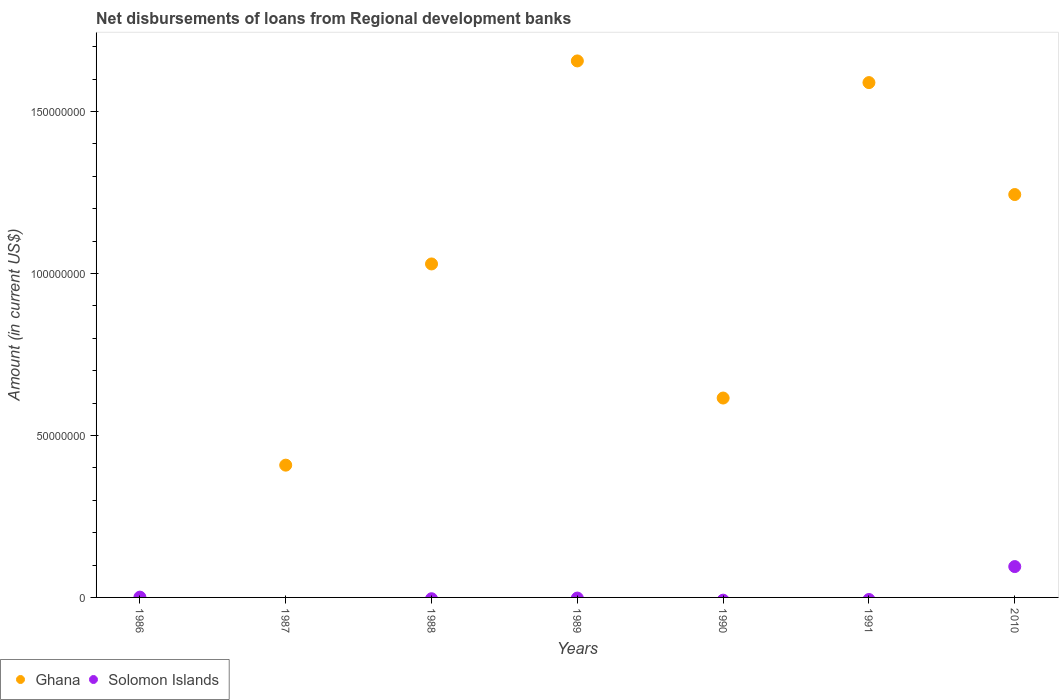How many different coloured dotlines are there?
Your response must be concise. 2. Is the number of dotlines equal to the number of legend labels?
Make the answer very short. No. What is the amount of disbursements of loans from regional development banks in Ghana in 1990?
Ensure brevity in your answer.  6.15e+07. Across all years, what is the maximum amount of disbursements of loans from regional development banks in Solomon Islands?
Offer a very short reply. 9.52e+06. In which year was the amount of disbursements of loans from regional development banks in Solomon Islands maximum?
Offer a terse response. 2010. What is the total amount of disbursements of loans from regional development banks in Ghana in the graph?
Provide a short and direct response. 6.54e+08. What is the difference between the amount of disbursements of loans from regional development banks in Ghana in 1989 and that in 2010?
Your response must be concise. 4.12e+07. What is the difference between the amount of disbursements of loans from regional development banks in Solomon Islands in 1988 and the amount of disbursements of loans from regional development banks in Ghana in 2010?
Offer a terse response. -1.24e+08. What is the average amount of disbursements of loans from regional development banks in Ghana per year?
Keep it short and to the point. 9.35e+07. What is the ratio of the amount of disbursements of loans from regional development banks in Ghana in 1990 to that in 1991?
Keep it short and to the point. 0.39. What is the difference between the highest and the second highest amount of disbursements of loans from regional development banks in Ghana?
Ensure brevity in your answer.  6.69e+06. What is the difference between the highest and the lowest amount of disbursements of loans from regional development banks in Ghana?
Offer a very short reply. 1.66e+08. Is the sum of the amount of disbursements of loans from regional development banks in Ghana in 1987 and 1988 greater than the maximum amount of disbursements of loans from regional development banks in Solomon Islands across all years?
Your answer should be compact. Yes. Does the amount of disbursements of loans from regional development banks in Ghana monotonically increase over the years?
Your answer should be very brief. No. Is the amount of disbursements of loans from regional development banks in Solomon Islands strictly greater than the amount of disbursements of loans from regional development banks in Ghana over the years?
Keep it short and to the point. No. How many dotlines are there?
Give a very brief answer. 2. How many legend labels are there?
Your answer should be very brief. 2. What is the title of the graph?
Your answer should be compact. Net disbursements of loans from Regional development banks. What is the label or title of the X-axis?
Ensure brevity in your answer.  Years. What is the label or title of the Y-axis?
Offer a terse response. Amount (in current US$). What is the Amount (in current US$) of Ghana in 1986?
Provide a short and direct response. 0. What is the Amount (in current US$) of Solomon Islands in 1986?
Your answer should be compact. 9.10e+04. What is the Amount (in current US$) in Ghana in 1987?
Your answer should be very brief. 4.08e+07. What is the Amount (in current US$) in Ghana in 1988?
Your response must be concise. 1.03e+08. What is the Amount (in current US$) of Solomon Islands in 1988?
Make the answer very short. 0. What is the Amount (in current US$) in Ghana in 1989?
Your response must be concise. 1.66e+08. What is the Amount (in current US$) of Ghana in 1990?
Provide a short and direct response. 6.15e+07. What is the Amount (in current US$) in Solomon Islands in 1990?
Offer a very short reply. 0. What is the Amount (in current US$) of Ghana in 1991?
Offer a very short reply. 1.59e+08. What is the Amount (in current US$) in Solomon Islands in 1991?
Keep it short and to the point. 0. What is the Amount (in current US$) of Ghana in 2010?
Ensure brevity in your answer.  1.24e+08. What is the Amount (in current US$) of Solomon Islands in 2010?
Offer a terse response. 9.52e+06. Across all years, what is the maximum Amount (in current US$) in Ghana?
Provide a succinct answer. 1.66e+08. Across all years, what is the maximum Amount (in current US$) in Solomon Islands?
Offer a terse response. 9.52e+06. Across all years, what is the minimum Amount (in current US$) in Ghana?
Offer a terse response. 0. Across all years, what is the minimum Amount (in current US$) in Solomon Islands?
Your response must be concise. 0. What is the total Amount (in current US$) in Ghana in the graph?
Ensure brevity in your answer.  6.54e+08. What is the total Amount (in current US$) in Solomon Islands in the graph?
Your answer should be compact. 9.61e+06. What is the difference between the Amount (in current US$) in Solomon Islands in 1986 and that in 2010?
Give a very brief answer. -9.43e+06. What is the difference between the Amount (in current US$) of Ghana in 1987 and that in 1988?
Offer a very short reply. -6.21e+07. What is the difference between the Amount (in current US$) of Ghana in 1987 and that in 1989?
Ensure brevity in your answer.  -1.25e+08. What is the difference between the Amount (in current US$) of Ghana in 1987 and that in 1990?
Offer a very short reply. -2.07e+07. What is the difference between the Amount (in current US$) in Ghana in 1987 and that in 1991?
Provide a short and direct response. -1.18e+08. What is the difference between the Amount (in current US$) in Ghana in 1987 and that in 2010?
Give a very brief answer. -8.35e+07. What is the difference between the Amount (in current US$) in Ghana in 1988 and that in 1989?
Keep it short and to the point. -6.27e+07. What is the difference between the Amount (in current US$) of Ghana in 1988 and that in 1990?
Ensure brevity in your answer.  4.14e+07. What is the difference between the Amount (in current US$) of Ghana in 1988 and that in 1991?
Provide a short and direct response. -5.60e+07. What is the difference between the Amount (in current US$) of Ghana in 1988 and that in 2010?
Offer a very short reply. -2.14e+07. What is the difference between the Amount (in current US$) of Ghana in 1989 and that in 1990?
Give a very brief answer. 1.04e+08. What is the difference between the Amount (in current US$) in Ghana in 1989 and that in 1991?
Give a very brief answer. 6.69e+06. What is the difference between the Amount (in current US$) in Ghana in 1989 and that in 2010?
Make the answer very short. 4.12e+07. What is the difference between the Amount (in current US$) in Ghana in 1990 and that in 1991?
Make the answer very short. -9.74e+07. What is the difference between the Amount (in current US$) in Ghana in 1990 and that in 2010?
Your answer should be compact. -6.28e+07. What is the difference between the Amount (in current US$) of Ghana in 1991 and that in 2010?
Make the answer very short. 3.46e+07. What is the difference between the Amount (in current US$) of Ghana in 1987 and the Amount (in current US$) of Solomon Islands in 2010?
Provide a short and direct response. 3.13e+07. What is the difference between the Amount (in current US$) in Ghana in 1988 and the Amount (in current US$) in Solomon Islands in 2010?
Offer a very short reply. 9.34e+07. What is the difference between the Amount (in current US$) of Ghana in 1989 and the Amount (in current US$) of Solomon Islands in 2010?
Provide a short and direct response. 1.56e+08. What is the difference between the Amount (in current US$) of Ghana in 1990 and the Amount (in current US$) of Solomon Islands in 2010?
Offer a terse response. 5.20e+07. What is the difference between the Amount (in current US$) in Ghana in 1991 and the Amount (in current US$) in Solomon Islands in 2010?
Your response must be concise. 1.49e+08. What is the average Amount (in current US$) of Ghana per year?
Make the answer very short. 9.35e+07. What is the average Amount (in current US$) of Solomon Islands per year?
Offer a very short reply. 1.37e+06. In the year 2010, what is the difference between the Amount (in current US$) of Ghana and Amount (in current US$) of Solomon Islands?
Provide a short and direct response. 1.15e+08. What is the ratio of the Amount (in current US$) in Solomon Islands in 1986 to that in 2010?
Keep it short and to the point. 0.01. What is the ratio of the Amount (in current US$) of Ghana in 1987 to that in 1988?
Keep it short and to the point. 0.4. What is the ratio of the Amount (in current US$) of Ghana in 1987 to that in 1989?
Offer a very short reply. 0.25. What is the ratio of the Amount (in current US$) of Ghana in 1987 to that in 1990?
Your answer should be compact. 0.66. What is the ratio of the Amount (in current US$) in Ghana in 1987 to that in 1991?
Keep it short and to the point. 0.26. What is the ratio of the Amount (in current US$) of Ghana in 1987 to that in 2010?
Offer a terse response. 0.33. What is the ratio of the Amount (in current US$) of Ghana in 1988 to that in 1989?
Make the answer very short. 0.62. What is the ratio of the Amount (in current US$) in Ghana in 1988 to that in 1990?
Offer a very short reply. 1.67. What is the ratio of the Amount (in current US$) in Ghana in 1988 to that in 1991?
Your answer should be compact. 0.65. What is the ratio of the Amount (in current US$) of Ghana in 1988 to that in 2010?
Provide a short and direct response. 0.83. What is the ratio of the Amount (in current US$) of Ghana in 1989 to that in 1990?
Offer a terse response. 2.69. What is the ratio of the Amount (in current US$) in Ghana in 1989 to that in 1991?
Your answer should be very brief. 1.04. What is the ratio of the Amount (in current US$) of Ghana in 1989 to that in 2010?
Offer a very short reply. 1.33. What is the ratio of the Amount (in current US$) in Ghana in 1990 to that in 1991?
Offer a terse response. 0.39. What is the ratio of the Amount (in current US$) of Ghana in 1990 to that in 2010?
Offer a terse response. 0.49. What is the ratio of the Amount (in current US$) in Ghana in 1991 to that in 2010?
Ensure brevity in your answer.  1.28. What is the difference between the highest and the second highest Amount (in current US$) of Ghana?
Your answer should be very brief. 6.69e+06. What is the difference between the highest and the lowest Amount (in current US$) in Ghana?
Provide a short and direct response. 1.66e+08. What is the difference between the highest and the lowest Amount (in current US$) in Solomon Islands?
Your answer should be very brief. 9.52e+06. 